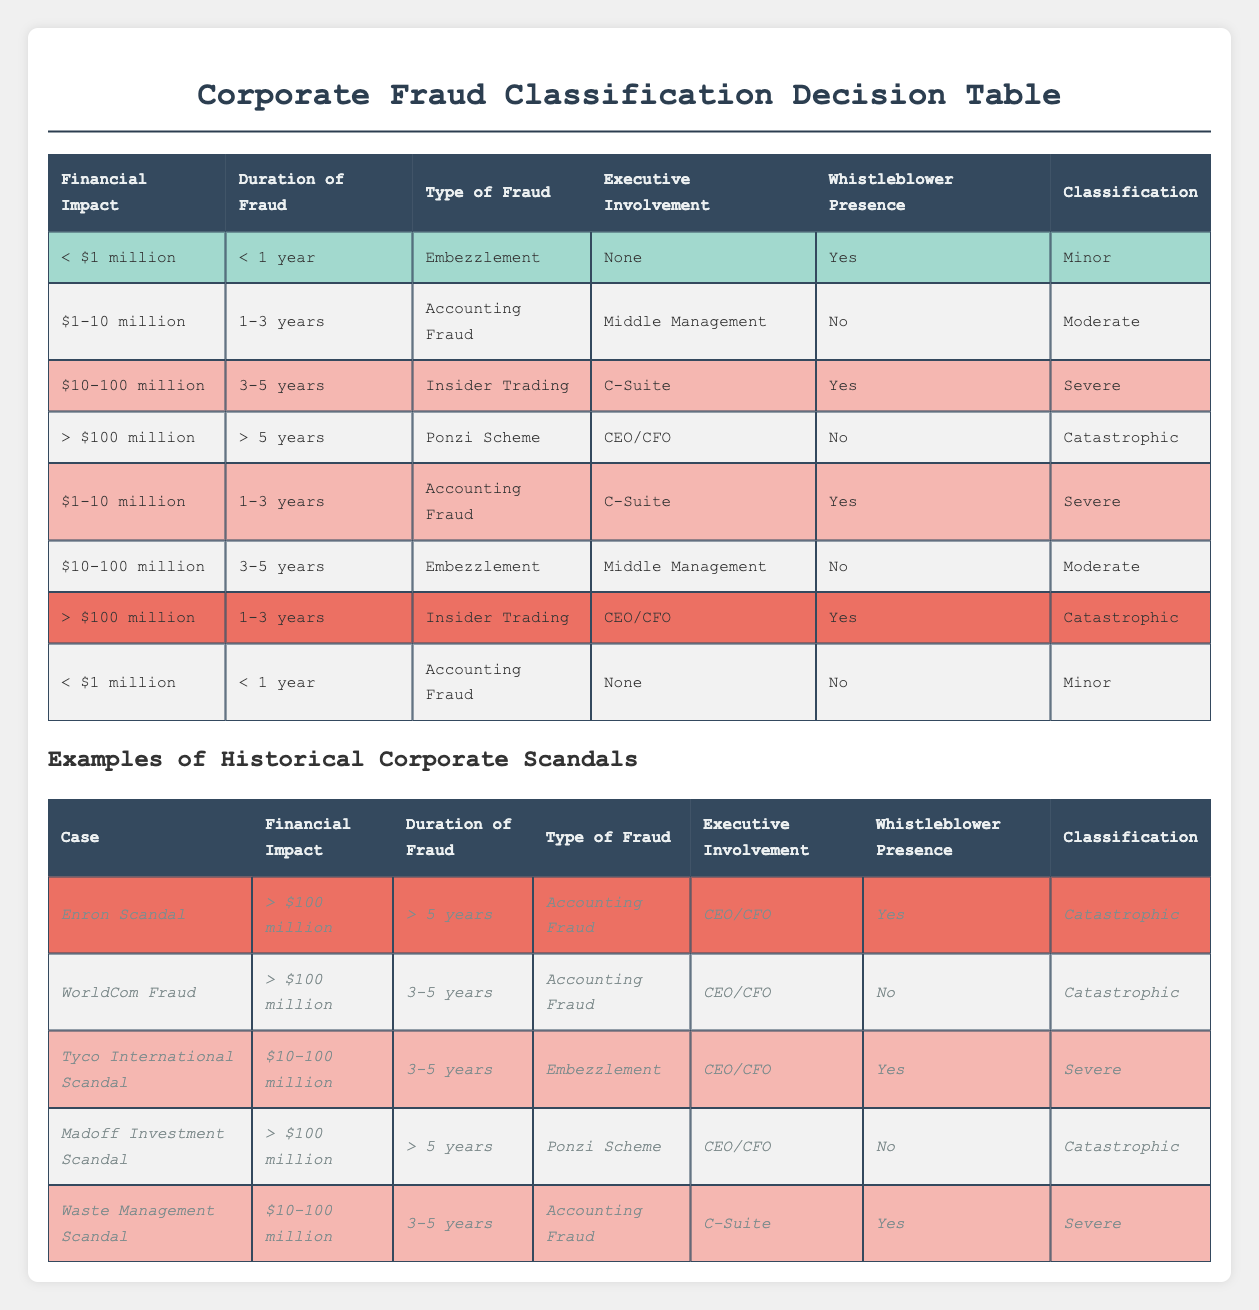What classification is assigned to fraud cases with a financial impact between $1-10 million? In the table, we look for any rows that list "Financial Impact" as "$1-10 million". There are two rows under this category, which classify the fraud cases as "Moderate" and "Severe". Therefore, we can say that fraud in this financial range can be classified as either "Moderate" or "Severe".
Answer: Moderate and Severe Is there any case listed with both CEO/CFO involvement and a whistleblower present? To answer this, we need to check the "Executive Involvement" and "Whistleblower Presence" columns. Reviewing the table, no cases meet both conditions of having "CEO/CFO" involvement where there is a "Yes" in the whistleblower presence. Therefore, the answer is no.
Answer: No How many cases involve embezzlement? We look for entries under the "Type of Fraud" column that specify "Embezzlement". There are three instances in the table: one with no executive involvement and the presence of a whistleblower, another with CEO/CFO involvement and a whistleblower presence, and one with middle management involvement and no whistleblower. This totals three cases involving embezzlement.
Answer: Three What is the classification for fraud duration of between 1-3 years with C-Suite involvement? We identify rows with "Duration of Fraud" as "1-3 years" and "Executive Involvement" as "C-Suite". There is one case fitting this description, which classifies the case as "Severe". Therefore, the classification for this combination is Severe.
Answer: Severe Which type of fraud corresponds to catastrophic classification without a whistleblower? We look for instances in the "Classification" column labeled "Catastrophic" while ensuring that "Whistleblower Presence" is "No". Reviewing the table, we find two cases: one with "Ponzi Scheme" and the other with "Accounting Fraud". So, the types of fraud corresponding to this classification are "Ponzi Scheme" and "Accounting Fraud".
Answer: Ponzi Scheme and Accounting Fraud If the financial impact exceeds $100 million, what is the minimum fraud duration for a catastrophic classification? We search for cases with a financial impact of "> $100 million" and examine the corresponding "Duration of Fraud" entries. The table shows a "Catastrophic" classification only for those cases where the fraud duration is "> 5 years". Therefore, the minimum fraud duration for this classification is "> 5 years".
Answer: > 5 years How many cases are categorized as minor? Reviewing the classification section of the table, there are only two entries that indicate "Minor". Therefore, the total number of cases categorized as minor is two.
Answer: Two What is the average financial impact for cases classified as severe? We calculate the average financial impact from the severe cases. The two financial impacts for severe classifications in the table are "$10-100 million" (considered as an average of $55 million for this calculation) and "$10-100 million" (again referred to as $55 million), quite similar to the one above. Summing these gives $110 million for the two cases, then dividing by 2 gives an average of $55 million.
Answer: $55 million 